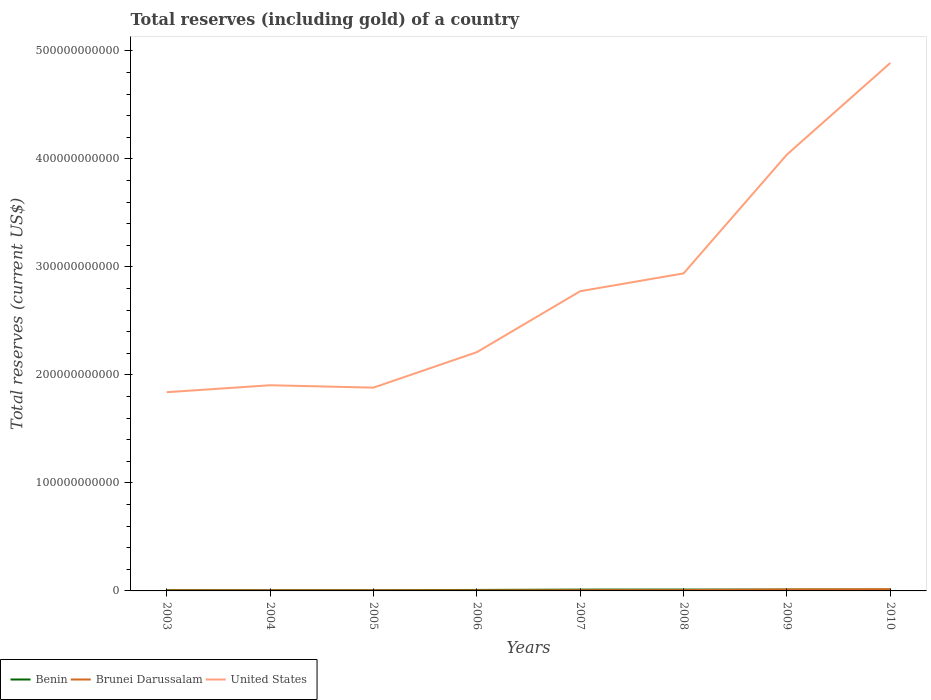How many different coloured lines are there?
Make the answer very short. 3. Does the line corresponding to United States intersect with the line corresponding to Brunei Darussalam?
Offer a terse response. No. Is the number of lines equal to the number of legend labels?
Your answer should be very brief. Yes. Across all years, what is the maximum total reserves (including gold) in United States?
Your answer should be compact. 1.84e+11. What is the total total reserves (including gold) in United States in the graph?
Your response must be concise. -9.35e+1. What is the difference between the highest and the second highest total reserves (including gold) in United States?
Your answer should be compact. 3.05e+11. How many years are there in the graph?
Provide a short and direct response. 8. What is the difference between two consecutive major ticks on the Y-axis?
Offer a very short reply. 1.00e+11. Are the values on the major ticks of Y-axis written in scientific E-notation?
Give a very brief answer. No. Does the graph contain any zero values?
Your answer should be compact. No. Does the graph contain grids?
Provide a succinct answer. No. How are the legend labels stacked?
Provide a succinct answer. Horizontal. What is the title of the graph?
Provide a short and direct response. Total reserves (including gold) of a country. What is the label or title of the X-axis?
Your answer should be compact. Years. What is the label or title of the Y-axis?
Give a very brief answer. Total reserves (current US$). What is the Total reserves (current US$) of Benin in 2003?
Make the answer very short. 7.18e+08. What is the Total reserves (current US$) of Brunei Darussalam in 2003?
Keep it short and to the point. 4.75e+08. What is the Total reserves (current US$) of United States in 2003?
Your answer should be compact. 1.84e+11. What is the Total reserves (current US$) of Benin in 2004?
Your response must be concise. 6.35e+08. What is the Total reserves (current US$) in Brunei Darussalam in 2004?
Give a very brief answer. 4.89e+08. What is the Total reserves (current US$) of United States in 2004?
Provide a succinct answer. 1.90e+11. What is the Total reserves (current US$) in Benin in 2005?
Provide a succinct answer. 6.55e+08. What is the Total reserves (current US$) in Brunei Darussalam in 2005?
Provide a short and direct response. 4.92e+08. What is the Total reserves (current US$) in United States in 2005?
Your answer should be compact. 1.88e+11. What is the Total reserves (current US$) of Benin in 2006?
Offer a very short reply. 9.12e+08. What is the Total reserves (current US$) in Brunei Darussalam in 2006?
Ensure brevity in your answer.  5.14e+08. What is the Total reserves (current US$) of United States in 2006?
Give a very brief answer. 2.21e+11. What is the Total reserves (current US$) of Benin in 2007?
Provide a short and direct response. 1.21e+09. What is the Total reserves (current US$) of Brunei Darussalam in 2007?
Provide a succinct answer. 6.67e+08. What is the Total reserves (current US$) of United States in 2007?
Provide a succinct answer. 2.78e+11. What is the Total reserves (current US$) in Benin in 2008?
Provide a short and direct response. 1.26e+09. What is the Total reserves (current US$) of Brunei Darussalam in 2008?
Provide a succinct answer. 7.51e+08. What is the Total reserves (current US$) in United States in 2008?
Offer a very short reply. 2.94e+11. What is the Total reserves (current US$) in Benin in 2009?
Keep it short and to the point. 1.23e+09. What is the Total reserves (current US$) of Brunei Darussalam in 2009?
Offer a very short reply. 1.36e+09. What is the Total reserves (current US$) in United States in 2009?
Ensure brevity in your answer.  4.04e+11. What is the Total reserves (current US$) in Benin in 2010?
Your answer should be very brief. 1.20e+09. What is the Total reserves (current US$) in Brunei Darussalam in 2010?
Offer a terse response. 1.56e+09. What is the Total reserves (current US$) of United States in 2010?
Offer a terse response. 4.89e+11. Across all years, what is the maximum Total reserves (current US$) in Benin?
Your answer should be very brief. 1.26e+09. Across all years, what is the maximum Total reserves (current US$) of Brunei Darussalam?
Your response must be concise. 1.56e+09. Across all years, what is the maximum Total reserves (current US$) of United States?
Your answer should be compact. 4.89e+11. Across all years, what is the minimum Total reserves (current US$) of Benin?
Provide a short and direct response. 6.35e+08. Across all years, what is the minimum Total reserves (current US$) of Brunei Darussalam?
Provide a succinct answer. 4.75e+08. Across all years, what is the minimum Total reserves (current US$) in United States?
Ensure brevity in your answer.  1.84e+11. What is the total Total reserves (current US$) in Benin in the graph?
Your response must be concise. 7.82e+09. What is the total Total reserves (current US$) in Brunei Darussalam in the graph?
Your answer should be compact. 6.31e+09. What is the total Total reserves (current US$) in United States in the graph?
Ensure brevity in your answer.  2.25e+12. What is the difference between the Total reserves (current US$) in Benin in 2003 and that in 2004?
Your answer should be very brief. 8.30e+07. What is the difference between the Total reserves (current US$) in Brunei Darussalam in 2003 and that in 2004?
Ensure brevity in your answer.  -1.41e+07. What is the difference between the Total reserves (current US$) in United States in 2003 and that in 2004?
Ensure brevity in your answer.  -6.44e+09. What is the difference between the Total reserves (current US$) of Benin in 2003 and that in 2005?
Ensure brevity in your answer.  6.33e+07. What is the difference between the Total reserves (current US$) in Brunei Darussalam in 2003 and that in 2005?
Make the answer very short. -1.71e+07. What is the difference between the Total reserves (current US$) of United States in 2003 and that in 2005?
Give a very brief answer. -4.23e+09. What is the difference between the Total reserves (current US$) of Benin in 2003 and that in 2006?
Your answer should be compact. -1.94e+08. What is the difference between the Total reserves (current US$) of Brunei Darussalam in 2003 and that in 2006?
Keep it short and to the point. -3.88e+07. What is the difference between the Total reserves (current US$) in United States in 2003 and that in 2006?
Offer a very short reply. -3.71e+1. What is the difference between the Total reserves (current US$) of Benin in 2003 and that in 2007?
Offer a terse response. -4.91e+08. What is the difference between the Total reserves (current US$) in Brunei Darussalam in 2003 and that in 2007?
Offer a terse response. -1.93e+08. What is the difference between the Total reserves (current US$) in United States in 2003 and that in 2007?
Your answer should be compact. -9.35e+1. What is the difference between the Total reserves (current US$) in Benin in 2003 and that in 2008?
Provide a short and direct response. -5.45e+08. What is the difference between the Total reserves (current US$) in Brunei Darussalam in 2003 and that in 2008?
Give a very brief answer. -2.76e+08. What is the difference between the Total reserves (current US$) in United States in 2003 and that in 2008?
Your answer should be compact. -1.10e+11. What is the difference between the Total reserves (current US$) of Benin in 2003 and that in 2009?
Provide a succinct answer. -5.12e+08. What is the difference between the Total reserves (current US$) of Brunei Darussalam in 2003 and that in 2009?
Make the answer very short. -8.83e+08. What is the difference between the Total reserves (current US$) in United States in 2003 and that in 2009?
Keep it short and to the point. -2.20e+11. What is the difference between the Total reserves (current US$) in Benin in 2003 and that in 2010?
Make the answer very short. -4.82e+08. What is the difference between the Total reserves (current US$) in Brunei Darussalam in 2003 and that in 2010?
Keep it short and to the point. -1.09e+09. What is the difference between the Total reserves (current US$) in United States in 2003 and that in 2010?
Keep it short and to the point. -3.05e+11. What is the difference between the Total reserves (current US$) of Benin in 2004 and that in 2005?
Offer a terse response. -1.97e+07. What is the difference between the Total reserves (current US$) of Brunei Darussalam in 2004 and that in 2005?
Ensure brevity in your answer.  -3.00e+06. What is the difference between the Total reserves (current US$) of United States in 2004 and that in 2005?
Offer a terse response. 2.21e+09. What is the difference between the Total reserves (current US$) of Benin in 2004 and that in 2006?
Provide a short and direct response. -2.77e+08. What is the difference between the Total reserves (current US$) in Brunei Darussalam in 2004 and that in 2006?
Your answer should be compact. -2.47e+07. What is the difference between the Total reserves (current US$) of United States in 2004 and that in 2006?
Offer a terse response. -3.06e+1. What is the difference between the Total reserves (current US$) in Benin in 2004 and that in 2007?
Make the answer very short. -5.74e+08. What is the difference between the Total reserves (current US$) of Brunei Darussalam in 2004 and that in 2007?
Your answer should be very brief. -1.79e+08. What is the difference between the Total reserves (current US$) of United States in 2004 and that in 2007?
Your answer should be very brief. -8.71e+1. What is the difference between the Total reserves (current US$) of Benin in 2004 and that in 2008?
Provide a succinct answer. -6.28e+08. What is the difference between the Total reserves (current US$) in Brunei Darussalam in 2004 and that in 2008?
Your answer should be compact. -2.62e+08. What is the difference between the Total reserves (current US$) of United States in 2004 and that in 2008?
Your response must be concise. -1.04e+11. What is the difference between the Total reserves (current US$) in Benin in 2004 and that in 2009?
Keep it short and to the point. -5.95e+08. What is the difference between the Total reserves (current US$) of Brunei Darussalam in 2004 and that in 2009?
Your response must be concise. -8.68e+08. What is the difference between the Total reserves (current US$) in United States in 2004 and that in 2009?
Provide a short and direct response. -2.14e+11. What is the difference between the Total reserves (current US$) in Benin in 2004 and that in 2010?
Offer a very short reply. -5.65e+08. What is the difference between the Total reserves (current US$) in Brunei Darussalam in 2004 and that in 2010?
Ensure brevity in your answer.  -1.07e+09. What is the difference between the Total reserves (current US$) of United States in 2004 and that in 2010?
Make the answer very short. -2.98e+11. What is the difference between the Total reserves (current US$) in Benin in 2005 and that in 2006?
Provide a short and direct response. -2.58e+08. What is the difference between the Total reserves (current US$) in Brunei Darussalam in 2005 and that in 2006?
Offer a very short reply. -2.17e+07. What is the difference between the Total reserves (current US$) in United States in 2005 and that in 2006?
Ensure brevity in your answer.  -3.28e+1. What is the difference between the Total reserves (current US$) in Benin in 2005 and that in 2007?
Your response must be concise. -5.55e+08. What is the difference between the Total reserves (current US$) of Brunei Darussalam in 2005 and that in 2007?
Offer a terse response. -1.76e+08. What is the difference between the Total reserves (current US$) of United States in 2005 and that in 2007?
Give a very brief answer. -8.93e+1. What is the difference between the Total reserves (current US$) of Benin in 2005 and that in 2008?
Your answer should be compact. -6.09e+08. What is the difference between the Total reserves (current US$) in Brunei Darussalam in 2005 and that in 2008?
Keep it short and to the point. -2.59e+08. What is the difference between the Total reserves (current US$) in United States in 2005 and that in 2008?
Provide a short and direct response. -1.06e+11. What is the difference between the Total reserves (current US$) of Benin in 2005 and that in 2009?
Offer a very short reply. -5.75e+08. What is the difference between the Total reserves (current US$) of Brunei Darussalam in 2005 and that in 2009?
Your response must be concise. -8.65e+08. What is the difference between the Total reserves (current US$) of United States in 2005 and that in 2009?
Your response must be concise. -2.16e+11. What is the difference between the Total reserves (current US$) in Benin in 2005 and that in 2010?
Offer a terse response. -5.46e+08. What is the difference between the Total reserves (current US$) in Brunei Darussalam in 2005 and that in 2010?
Keep it short and to the point. -1.07e+09. What is the difference between the Total reserves (current US$) of United States in 2005 and that in 2010?
Offer a very short reply. -3.01e+11. What is the difference between the Total reserves (current US$) of Benin in 2006 and that in 2007?
Offer a very short reply. -2.97e+08. What is the difference between the Total reserves (current US$) of Brunei Darussalam in 2006 and that in 2007?
Offer a terse response. -1.54e+08. What is the difference between the Total reserves (current US$) of United States in 2006 and that in 2007?
Ensure brevity in your answer.  -5.65e+1. What is the difference between the Total reserves (current US$) in Benin in 2006 and that in 2008?
Provide a short and direct response. -3.51e+08. What is the difference between the Total reserves (current US$) of Brunei Darussalam in 2006 and that in 2008?
Your answer should be compact. -2.38e+08. What is the difference between the Total reserves (current US$) of United States in 2006 and that in 2008?
Offer a terse response. -7.30e+1. What is the difference between the Total reserves (current US$) in Benin in 2006 and that in 2009?
Keep it short and to the point. -3.18e+08. What is the difference between the Total reserves (current US$) in Brunei Darussalam in 2006 and that in 2009?
Offer a very short reply. -8.44e+08. What is the difference between the Total reserves (current US$) in United States in 2006 and that in 2009?
Offer a very short reply. -1.83e+11. What is the difference between the Total reserves (current US$) in Benin in 2006 and that in 2010?
Keep it short and to the point. -2.88e+08. What is the difference between the Total reserves (current US$) of Brunei Darussalam in 2006 and that in 2010?
Provide a short and direct response. -1.05e+09. What is the difference between the Total reserves (current US$) in United States in 2006 and that in 2010?
Your response must be concise. -2.68e+11. What is the difference between the Total reserves (current US$) of Benin in 2007 and that in 2008?
Provide a short and direct response. -5.41e+07. What is the difference between the Total reserves (current US$) of Brunei Darussalam in 2007 and that in 2008?
Keep it short and to the point. -8.37e+07. What is the difference between the Total reserves (current US$) in United States in 2007 and that in 2008?
Your answer should be very brief. -1.65e+1. What is the difference between the Total reserves (current US$) in Benin in 2007 and that in 2009?
Give a very brief answer. -2.06e+07. What is the difference between the Total reserves (current US$) in Brunei Darussalam in 2007 and that in 2009?
Provide a succinct answer. -6.90e+08. What is the difference between the Total reserves (current US$) in United States in 2007 and that in 2009?
Offer a terse response. -1.27e+11. What is the difference between the Total reserves (current US$) in Benin in 2007 and that in 2010?
Provide a succinct answer. 9.15e+06. What is the difference between the Total reserves (current US$) in Brunei Darussalam in 2007 and that in 2010?
Your answer should be very brief. -8.96e+08. What is the difference between the Total reserves (current US$) of United States in 2007 and that in 2010?
Ensure brevity in your answer.  -2.11e+11. What is the difference between the Total reserves (current US$) in Benin in 2008 and that in 2009?
Keep it short and to the point. 3.35e+07. What is the difference between the Total reserves (current US$) of Brunei Darussalam in 2008 and that in 2009?
Keep it short and to the point. -6.06e+08. What is the difference between the Total reserves (current US$) of United States in 2008 and that in 2009?
Offer a terse response. -1.10e+11. What is the difference between the Total reserves (current US$) of Benin in 2008 and that in 2010?
Offer a very short reply. 6.33e+07. What is the difference between the Total reserves (current US$) in Brunei Darussalam in 2008 and that in 2010?
Make the answer very short. -8.12e+08. What is the difference between the Total reserves (current US$) of United States in 2008 and that in 2010?
Provide a short and direct response. -1.95e+11. What is the difference between the Total reserves (current US$) of Benin in 2009 and that in 2010?
Offer a terse response. 2.98e+07. What is the difference between the Total reserves (current US$) in Brunei Darussalam in 2009 and that in 2010?
Keep it short and to the point. -2.06e+08. What is the difference between the Total reserves (current US$) in United States in 2009 and that in 2010?
Make the answer very short. -8.48e+1. What is the difference between the Total reserves (current US$) of Benin in 2003 and the Total reserves (current US$) of Brunei Darussalam in 2004?
Your response must be concise. 2.29e+08. What is the difference between the Total reserves (current US$) of Benin in 2003 and the Total reserves (current US$) of United States in 2004?
Ensure brevity in your answer.  -1.90e+11. What is the difference between the Total reserves (current US$) in Brunei Darussalam in 2003 and the Total reserves (current US$) in United States in 2004?
Offer a very short reply. -1.90e+11. What is the difference between the Total reserves (current US$) in Benin in 2003 and the Total reserves (current US$) in Brunei Darussalam in 2005?
Provide a succinct answer. 2.26e+08. What is the difference between the Total reserves (current US$) in Benin in 2003 and the Total reserves (current US$) in United States in 2005?
Your response must be concise. -1.88e+11. What is the difference between the Total reserves (current US$) in Brunei Darussalam in 2003 and the Total reserves (current US$) in United States in 2005?
Keep it short and to the point. -1.88e+11. What is the difference between the Total reserves (current US$) of Benin in 2003 and the Total reserves (current US$) of Brunei Darussalam in 2006?
Ensure brevity in your answer.  2.04e+08. What is the difference between the Total reserves (current US$) of Benin in 2003 and the Total reserves (current US$) of United States in 2006?
Your answer should be compact. -2.20e+11. What is the difference between the Total reserves (current US$) of Brunei Darussalam in 2003 and the Total reserves (current US$) of United States in 2006?
Your answer should be very brief. -2.21e+11. What is the difference between the Total reserves (current US$) in Benin in 2003 and the Total reserves (current US$) in Brunei Darussalam in 2007?
Your response must be concise. 5.04e+07. What is the difference between the Total reserves (current US$) in Benin in 2003 and the Total reserves (current US$) in United States in 2007?
Offer a very short reply. -2.77e+11. What is the difference between the Total reserves (current US$) in Brunei Darussalam in 2003 and the Total reserves (current US$) in United States in 2007?
Your response must be concise. -2.77e+11. What is the difference between the Total reserves (current US$) of Benin in 2003 and the Total reserves (current US$) of Brunei Darussalam in 2008?
Give a very brief answer. -3.33e+07. What is the difference between the Total reserves (current US$) in Benin in 2003 and the Total reserves (current US$) in United States in 2008?
Ensure brevity in your answer.  -2.93e+11. What is the difference between the Total reserves (current US$) of Brunei Darussalam in 2003 and the Total reserves (current US$) of United States in 2008?
Offer a very short reply. -2.94e+11. What is the difference between the Total reserves (current US$) in Benin in 2003 and the Total reserves (current US$) in Brunei Darussalam in 2009?
Your response must be concise. -6.39e+08. What is the difference between the Total reserves (current US$) in Benin in 2003 and the Total reserves (current US$) in United States in 2009?
Provide a short and direct response. -4.03e+11. What is the difference between the Total reserves (current US$) of Brunei Darussalam in 2003 and the Total reserves (current US$) of United States in 2009?
Ensure brevity in your answer.  -4.04e+11. What is the difference between the Total reserves (current US$) in Benin in 2003 and the Total reserves (current US$) in Brunei Darussalam in 2010?
Make the answer very short. -8.45e+08. What is the difference between the Total reserves (current US$) of Benin in 2003 and the Total reserves (current US$) of United States in 2010?
Keep it short and to the point. -4.88e+11. What is the difference between the Total reserves (current US$) in Brunei Darussalam in 2003 and the Total reserves (current US$) in United States in 2010?
Give a very brief answer. -4.88e+11. What is the difference between the Total reserves (current US$) of Benin in 2004 and the Total reserves (current US$) of Brunei Darussalam in 2005?
Your answer should be compact. 1.43e+08. What is the difference between the Total reserves (current US$) in Benin in 2004 and the Total reserves (current US$) in United States in 2005?
Your answer should be compact. -1.88e+11. What is the difference between the Total reserves (current US$) of Brunei Darussalam in 2004 and the Total reserves (current US$) of United States in 2005?
Your answer should be very brief. -1.88e+11. What is the difference between the Total reserves (current US$) of Benin in 2004 and the Total reserves (current US$) of Brunei Darussalam in 2006?
Offer a terse response. 1.21e+08. What is the difference between the Total reserves (current US$) of Benin in 2004 and the Total reserves (current US$) of United States in 2006?
Make the answer very short. -2.20e+11. What is the difference between the Total reserves (current US$) in Brunei Darussalam in 2004 and the Total reserves (current US$) in United States in 2006?
Provide a succinct answer. -2.21e+11. What is the difference between the Total reserves (current US$) in Benin in 2004 and the Total reserves (current US$) in Brunei Darussalam in 2007?
Provide a short and direct response. -3.26e+07. What is the difference between the Total reserves (current US$) of Benin in 2004 and the Total reserves (current US$) of United States in 2007?
Your answer should be very brief. -2.77e+11. What is the difference between the Total reserves (current US$) in Brunei Darussalam in 2004 and the Total reserves (current US$) in United States in 2007?
Make the answer very short. -2.77e+11. What is the difference between the Total reserves (current US$) in Benin in 2004 and the Total reserves (current US$) in Brunei Darussalam in 2008?
Make the answer very short. -1.16e+08. What is the difference between the Total reserves (current US$) of Benin in 2004 and the Total reserves (current US$) of United States in 2008?
Your answer should be very brief. -2.93e+11. What is the difference between the Total reserves (current US$) of Brunei Darussalam in 2004 and the Total reserves (current US$) of United States in 2008?
Your answer should be compact. -2.94e+11. What is the difference between the Total reserves (current US$) in Benin in 2004 and the Total reserves (current US$) in Brunei Darussalam in 2009?
Offer a very short reply. -7.22e+08. What is the difference between the Total reserves (current US$) of Benin in 2004 and the Total reserves (current US$) of United States in 2009?
Offer a terse response. -4.03e+11. What is the difference between the Total reserves (current US$) in Brunei Darussalam in 2004 and the Total reserves (current US$) in United States in 2009?
Provide a succinct answer. -4.04e+11. What is the difference between the Total reserves (current US$) in Benin in 2004 and the Total reserves (current US$) in Brunei Darussalam in 2010?
Your answer should be very brief. -9.28e+08. What is the difference between the Total reserves (current US$) in Benin in 2004 and the Total reserves (current US$) in United States in 2010?
Your answer should be compact. -4.88e+11. What is the difference between the Total reserves (current US$) in Brunei Darussalam in 2004 and the Total reserves (current US$) in United States in 2010?
Provide a short and direct response. -4.88e+11. What is the difference between the Total reserves (current US$) of Benin in 2005 and the Total reserves (current US$) of Brunei Darussalam in 2006?
Provide a succinct answer. 1.41e+08. What is the difference between the Total reserves (current US$) in Benin in 2005 and the Total reserves (current US$) in United States in 2006?
Provide a succinct answer. -2.20e+11. What is the difference between the Total reserves (current US$) in Brunei Darussalam in 2005 and the Total reserves (current US$) in United States in 2006?
Ensure brevity in your answer.  -2.21e+11. What is the difference between the Total reserves (current US$) of Benin in 2005 and the Total reserves (current US$) of Brunei Darussalam in 2007?
Your response must be concise. -1.29e+07. What is the difference between the Total reserves (current US$) of Benin in 2005 and the Total reserves (current US$) of United States in 2007?
Keep it short and to the point. -2.77e+11. What is the difference between the Total reserves (current US$) in Brunei Darussalam in 2005 and the Total reserves (current US$) in United States in 2007?
Offer a terse response. -2.77e+11. What is the difference between the Total reserves (current US$) of Benin in 2005 and the Total reserves (current US$) of Brunei Darussalam in 2008?
Offer a very short reply. -9.66e+07. What is the difference between the Total reserves (current US$) of Benin in 2005 and the Total reserves (current US$) of United States in 2008?
Your response must be concise. -2.93e+11. What is the difference between the Total reserves (current US$) in Brunei Darussalam in 2005 and the Total reserves (current US$) in United States in 2008?
Your answer should be very brief. -2.94e+11. What is the difference between the Total reserves (current US$) in Benin in 2005 and the Total reserves (current US$) in Brunei Darussalam in 2009?
Make the answer very short. -7.03e+08. What is the difference between the Total reserves (current US$) in Benin in 2005 and the Total reserves (current US$) in United States in 2009?
Your response must be concise. -4.03e+11. What is the difference between the Total reserves (current US$) in Brunei Darussalam in 2005 and the Total reserves (current US$) in United States in 2009?
Provide a short and direct response. -4.04e+11. What is the difference between the Total reserves (current US$) of Benin in 2005 and the Total reserves (current US$) of Brunei Darussalam in 2010?
Make the answer very short. -9.09e+08. What is the difference between the Total reserves (current US$) in Benin in 2005 and the Total reserves (current US$) in United States in 2010?
Offer a very short reply. -4.88e+11. What is the difference between the Total reserves (current US$) of Brunei Darussalam in 2005 and the Total reserves (current US$) of United States in 2010?
Your answer should be very brief. -4.88e+11. What is the difference between the Total reserves (current US$) of Benin in 2006 and the Total reserves (current US$) of Brunei Darussalam in 2007?
Give a very brief answer. 2.45e+08. What is the difference between the Total reserves (current US$) of Benin in 2006 and the Total reserves (current US$) of United States in 2007?
Provide a succinct answer. -2.77e+11. What is the difference between the Total reserves (current US$) in Brunei Darussalam in 2006 and the Total reserves (current US$) in United States in 2007?
Your response must be concise. -2.77e+11. What is the difference between the Total reserves (current US$) in Benin in 2006 and the Total reserves (current US$) in Brunei Darussalam in 2008?
Offer a very short reply. 1.61e+08. What is the difference between the Total reserves (current US$) of Benin in 2006 and the Total reserves (current US$) of United States in 2008?
Ensure brevity in your answer.  -2.93e+11. What is the difference between the Total reserves (current US$) of Brunei Darussalam in 2006 and the Total reserves (current US$) of United States in 2008?
Your answer should be compact. -2.94e+11. What is the difference between the Total reserves (current US$) in Benin in 2006 and the Total reserves (current US$) in Brunei Darussalam in 2009?
Offer a terse response. -4.45e+08. What is the difference between the Total reserves (current US$) of Benin in 2006 and the Total reserves (current US$) of United States in 2009?
Provide a short and direct response. -4.03e+11. What is the difference between the Total reserves (current US$) in Brunei Darussalam in 2006 and the Total reserves (current US$) in United States in 2009?
Offer a terse response. -4.04e+11. What is the difference between the Total reserves (current US$) of Benin in 2006 and the Total reserves (current US$) of Brunei Darussalam in 2010?
Offer a very short reply. -6.51e+08. What is the difference between the Total reserves (current US$) in Benin in 2006 and the Total reserves (current US$) in United States in 2010?
Offer a very short reply. -4.88e+11. What is the difference between the Total reserves (current US$) of Brunei Darussalam in 2006 and the Total reserves (current US$) of United States in 2010?
Your answer should be very brief. -4.88e+11. What is the difference between the Total reserves (current US$) in Benin in 2007 and the Total reserves (current US$) in Brunei Darussalam in 2008?
Provide a short and direct response. 4.58e+08. What is the difference between the Total reserves (current US$) of Benin in 2007 and the Total reserves (current US$) of United States in 2008?
Keep it short and to the point. -2.93e+11. What is the difference between the Total reserves (current US$) of Brunei Darussalam in 2007 and the Total reserves (current US$) of United States in 2008?
Your answer should be very brief. -2.93e+11. What is the difference between the Total reserves (current US$) of Benin in 2007 and the Total reserves (current US$) of Brunei Darussalam in 2009?
Provide a short and direct response. -1.48e+08. What is the difference between the Total reserves (current US$) in Benin in 2007 and the Total reserves (current US$) in United States in 2009?
Ensure brevity in your answer.  -4.03e+11. What is the difference between the Total reserves (current US$) of Brunei Darussalam in 2007 and the Total reserves (current US$) of United States in 2009?
Provide a short and direct response. -4.03e+11. What is the difference between the Total reserves (current US$) of Benin in 2007 and the Total reserves (current US$) of Brunei Darussalam in 2010?
Keep it short and to the point. -3.54e+08. What is the difference between the Total reserves (current US$) in Benin in 2007 and the Total reserves (current US$) in United States in 2010?
Keep it short and to the point. -4.88e+11. What is the difference between the Total reserves (current US$) of Brunei Darussalam in 2007 and the Total reserves (current US$) of United States in 2010?
Ensure brevity in your answer.  -4.88e+11. What is the difference between the Total reserves (current US$) of Benin in 2008 and the Total reserves (current US$) of Brunei Darussalam in 2009?
Your answer should be compact. -9.39e+07. What is the difference between the Total reserves (current US$) in Benin in 2008 and the Total reserves (current US$) in United States in 2009?
Give a very brief answer. -4.03e+11. What is the difference between the Total reserves (current US$) in Brunei Darussalam in 2008 and the Total reserves (current US$) in United States in 2009?
Make the answer very short. -4.03e+11. What is the difference between the Total reserves (current US$) in Benin in 2008 and the Total reserves (current US$) in Brunei Darussalam in 2010?
Provide a short and direct response. -3.00e+08. What is the difference between the Total reserves (current US$) of Benin in 2008 and the Total reserves (current US$) of United States in 2010?
Make the answer very short. -4.88e+11. What is the difference between the Total reserves (current US$) of Brunei Darussalam in 2008 and the Total reserves (current US$) of United States in 2010?
Your answer should be compact. -4.88e+11. What is the difference between the Total reserves (current US$) in Benin in 2009 and the Total reserves (current US$) in Brunei Darussalam in 2010?
Give a very brief answer. -3.33e+08. What is the difference between the Total reserves (current US$) in Benin in 2009 and the Total reserves (current US$) in United States in 2010?
Give a very brief answer. -4.88e+11. What is the difference between the Total reserves (current US$) in Brunei Darussalam in 2009 and the Total reserves (current US$) in United States in 2010?
Keep it short and to the point. -4.88e+11. What is the average Total reserves (current US$) of Benin per year?
Ensure brevity in your answer.  9.78e+08. What is the average Total reserves (current US$) in Brunei Darussalam per year?
Make the answer very short. 7.89e+08. What is the average Total reserves (current US$) in United States per year?
Keep it short and to the point. 2.81e+11. In the year 2003, what is the difference between the Total reserves (current US$) in Benin and Total reserves (current US$) in Brunei Darussalam?
Provide a short and direct response. 2.43e+08. In the year 2003, what is the difference between the Total reserves (current US$) of Benin and Total reserves (current US$) of United States?
Make the answer very short. -1.83e+11. In the year 2003, what is the difference between the Total reserves (current US$) in Brunei Darussalam and Total reserves (current US$) in United States?
Offer a very short reply. -1.84e+11. In the year 2004, what is the difference between the Total reserves (current US$) of Benin and Total reserves (current US$) of Brunei Darussalam?
Keep it short and to the point. 1.46e+08. In the year 2004, what is the difference between the Total reserves (current US$) of Benin and Total reserves (current US$) of United States?
Ensure brevity in your answer.  -1.90e+11. In the year 2004, what is the difference between the Total reserves (current US$) in Brunei Darussalam and Total reserves (current US$) in United States?
Give a very brief answer. -1.90e+11. In the year 2005, what is the difference between the Total reserves (current US$) in Benin and Total reserves (current US$) in Brunei Darussalam?
Offer a terse response. 1.63e+08. In the year 2005, what is the difference between the Total reserves (current US$) of Benin and Total reserves (current US$) of United States?
Your answer should be compact. -1.88e+11. In the year 2005, what is the difference between the Total reserves (current US$) in Brunei Darussalam and Total reserves (current US$) in United States?
Your response must be concise. -1.88e+11. In the year 2006, what is the difference between the Total reserves (current US$) of Benin and Total reserves (current US$) of Brunei Darussalam?
Make the answer very short. 3.99e+08. In the year 2006, what is the difference between the Total reserves (current US$) of Benin and Total reserves (current US$) of United States?
Your answer should be compact. -2.20e+11. In the year 2006, what is the difference between the Total reserves (current US$) in Brunei Darussalam and Total reserves (current US$) in United States?
Keep it short and to the point. -2.21e+11. In the year 2007, what is the difference between the Total reserves (current US$) in Benin and Total reserves (current US$) in Brunei Darussalam?
Ensure brevity in your answer.  5.42e+08. In the year 2007, what is the difference between the Total reserves (current US$) in Benin and Total reserves (current US$) in United States?
Make the answer very short. -2.76e+11. In the year 2007, what is the difference between the Total reserves (current US$) of Brunei Darussalam and Total reserves (current US$) of United States?
Your response must be concise. -2.77e+11. In the year 2008, what is the difference between the Total reserves (current US$) of Benin and Total reserves (current US$) of Brunei Darussalam?
Your response must be concise. 5.12e+08. In the year 2008, what is the difference between the Total reserves (current US$) in Benin and Total reserves (current US$) in United States?
Your answer should be compact. -2.93e+11. In the year 2008, what is the difference between the Total reserves (current US$) in Brunei Darussalam and Total reserves (current US$) in United States?
Your answer should be compact. -2.93e+11. In the year 2009, what is the difference between the Total reserves (current US$) in Benin and Total reserves (current US$) in Brunei Darussalam?
Keep it short and to the point. -1.27e+08. In the year 2009, what is the difference between the Total reserves (current US$) in Benin and Total reserves (current US$) in United States?
Your response must be concise. -4.03e+11. In the year 2009, what is the difference between the Total reserves (current US$) of Brunei Darussalam and Total reserves (current US$) of United States?
Keep it short and to the point. -4.03e+11. In the year 2010, what is the difference between the Total reserves (current US$) of Benin and Total reserves (current US$) of Brunei Darussalam?
Make the answer very short. -3.63e+08. In the year 2010, what is the difference between the Total reserves (current US$) of Benin and Total reserves (current US$) of United States?
Make the answer very short. -4.88e+11. In the year 2010, what is the difference between the Total reserves (current US$) in Brunei Darussalam and Total reserves (current US$) in United States?
Make the answer very short. -4.87e+11. What is the ratio of the Total reserves (current US$) in Benin in 2003 to that in 2004?
Provide a succinct answer. 1.13. What is the ratio of the Total reserves (current US$) in Brunei Darussalam in 2003 to that in 2004?
Offer a terse response. 0.97. What is the ratio of the Total reserves (current US$) in United States in 2003 to that in 2004?
Your answer should be compact. 0.97. What is the ratio of the Total reserves (current US$) in Benin in 2003 to that in 2005?
Offer a very short reply. 1.1. What is the ratio of the Total reserves (current US$) of Brunei Darussalam in 2003 to that in 2005?
Make the answer very short. 0.97. What is the ratio of the Total reserves (current US$) of United States in 2003 to that in 2005?
Make the answer very short. 0.98. What is the ratio of the Total reserves (current US$) in Benin in 2003 to that in 2006?
Your answer should be compact. 0.79. What is the ratio of the Total reserves (current US$) in Brunei Darussalam in 2003 to that in 2006?
Ensure brevity in your answer.  0.92. What is the ratio of the Total reserves (current US$) in United States in 2003 to that in 2006?
Give a very brief answer. 0.83. What is the ratio of the Total reserves (current US$) of Benin in 2003 to that in 2007?
Give a very brief answer. 0.59. What is the ratio of the Total reserves (current US$) in Brunei Darussalam in 2003 to that in 2007?
Your answer should be compact. 0.71. What is the ratio of the Total reserves (current US$) of United States in 2003 to that in 2007?
Offer a very short reply. 0.66. What is the ratio of the Total reserves (current US$) of Benin in 2003 to that in 2008?
Make the answer very short. 0.57. What is the ratio of the Total reserves (current US$) of Brunei Darussalam in 2003 to that in 2008?
Offer a very short reply. 0.63. What is the ratio of the Total reserves (current US$) of United States in 2003 to that in 2008?
Your answer should be very brief. 0.63. What is the ratio of the Total reserves (current US$) in Benin in 2003 to that in 2009?
Keep it short and to the point. 0.58. What is the ratio of the Total reserves (current US$) of Brunei Darussalam in 2003 to that in 2009?
Ensure brevity in your answer.  0.35. What is the ratio of the Total reserves (current US$) in United States in 2003 to that in 2009?
Ensure brevity in your answer.  0.46. What is the ratio of the Total reserves (current US$) in Benin in 2003 to that in 2010?
Give a very brief answer. 0.6. What is the ratio of the Total reserves (current US$) of Brunei Darussalam in 2003 to that in 2010?
Keep it short and to the point. 0.3. What is the ratio of the Total reserves (current US$) in United States in 2003 to that in 2010?
Ensure brevity in your answer.  0.38. What is the ratio of the Total reserves (current US$) in United States in 2004 to that in 2005?
Your answer should be very brief. 1.01. What is the ratio of the Total reserves (current US$) of Benin in 2004 to that in 2006?
Provide a short and direct response. 0.7. What is the ratio of the Total reserves (current US$) of Brunei Darussalam in 2004 to that in 2006?
Provide a short and direct response. 0.95. What is the ratio of the Total reserves (current US$) of United States in 2004 to that in 2006?
Offer a terse response. 0.86. What is the ratio of the Total reserves (current US$) in Benin in 2004 to that in 2007?
Make the answer very short. 0.53. What is the ratio of the Total reserves (current US$) of Brunei Darussalam in 2004 to that in 2007?
Offer a terse response. 0.73. What is the ratio of the Total reserves (current US$) of United States in 2004 to that in 2007?
Ensure brevity in your answer.  0.69. What is the ratio of the Total reserves (current US$) of Benin in 2004 to that in 2008?
Ensure brevity in your answer.  0.5. What is the ratio of the Total reserves (current US$) of Brunei Darussalam in 2004 to that in 2008?
Your response must be concise. 0.65. What is the ratio of the Total reserves (current US$) in United States in 2004 to that in 2008?
Your answer should be very brief. 0.65. What is the ratio of the Total reserves (current US$) in Benin in 2004 to that in 2009?
Your answer should be very brief. 0.52. What is the ratio of the Total reserves (current US$) in Brunei Darussalam in 2004 to that in 2009?
Offer a very short reply. 0.36. What is the ratio of the Total reserves (current US$) of United States in 2004 to that in 2009?
Provide a short and direct response. 0.47. What is the ratio of the Total reserves (current US$) of Benin in 2004 to that in 2010?
Keep it short and to the point. 0.53. What is the ratio of the Total reserves (current US$) in Brunei Darussalam in 2004 to that in 2010?
Your response must be concise. 0.31. What is the ratio of the Total reserves (current US$) of United States in 2004 to that in 2010?
Provide a succinct answer. 0.39. What is the ratio of the Total reserves (current US$) in Benin in 2005 to that in 2006?
Provide a succinct answer. 0.72. What is the ratio of the Total reserves (current US$) in Brunei Darussalam in 2005 to that in 2006?
Your answer should be very brief. 0.96. What is the ratio of the Total reserves (current US$) of United States in 2005 to that in 2006?
Make the answer very short. 0.85. What is the ratio of the Total reserves (current US$) of Benin in 2005 to that in 2007?
Provide a succinct answer. 0.54. What is the ratio of the Total reserves (current US$) of Brunei Darussalam in 2005 to that in 2007?
Ensure brevity in your answer.  0.74. What is the ratio of the Total reserves (current US$) in United States in 2005 to that in 2007?
Offer a very short reply. 0.68. What is the ratio of the Total reserves (current US$) in Benin in 2005 to that in 2008?
Provide a short and direct response. 0.52. What is the ratio of the Total reserves (current US$) of Brunei Darussalam in 2005 to that in 2008?
Your answer should be very brief. 0.65. What is the ratio of the Total reserves (current US$) in United States in 2005 to that in 2008?
Make the answer very short. 0.64. What is the ratio of the Total reserves (current US$) in Benin in 2005 to that in 2009?
Offer a terse response. 0.53. What is the ratio of the Total reserves (current US$) of Brunei Darussalam in 2005 to that in 2009?
Make the answer very short. 0.36. What is the ratio of the Total reserves (current US$) in United States in 2005 to that in 2009?
Offer a terse response. 0.47. What is the ratio of the Total reserves (current US$) in Benin in 2005 to that in 2010?
Your answer should be compact. 0.55. What is the ratio of the Total reserves (current US$) of Brunei Darussalam in 2005 to that in 2010?
Your answer should be very brief. 0.31. What is the ratio of the Total reserves (current US$) of United States in 2005 to that in 2010?
Offer a terse response. 0.39. What is the ratio of the Total reserves (current US$) in Benin in 2006 to that in 2007?
Give a very brief answer. 0.75. What is the ratio of the Total reserves (current US$) of Brunei Darussalam in 2006 to that in 2007?
Ensure brevity in your answer.  0.77. What is the ratio of the Total reserves (current US$) in United States in 2006 to that in 2007?
Ensure brevity in your answer.  0.8. What is the ratio of the Total reserves (current US$) of Benin in 2006 to that in 2008?
Your response must be concise. 0.72. What is the ratio of the Total reserves (current US$) of Brunei Darussalam in 2006 to that in 2008?
Make the answer very short. 0.68. What is the ratio of the Total reserves (current US$) of United States in 2006 to that in 2008?
Make the answer very short. 0.75. What is the ratio of the Total reserves (current US$) in Benin in 2006 to that in 2009?
Provide a short and direct response. 0.74. What is the ratio of the Total reserves (current US$) in Brunei Darussalam in 2006 to that in 2009?
Give a very brief answer. 0.38. What is the ratio of the Total reserves (current US$) in United States in 2006 to that in 2009?
Provide a short and direct response. 0.55. What is the ratio of the Total reserves (current US$) of Benin in 2006 to that in 2010?
Give a very brief answer. 0.76. What is the ratio of the Total reserves (current US$) of Brunei Darussalam in 2006 to that in 2010?
Provide a succinct answer. 0.33. What is the ratio of the Total reserves (current US$) in United States in 2006 to that in 2010?
Give a very brief answer. 0.45. What is the ratio of the Total reserves (current US$) of Benin in 2007 to that in 2008?
Keep it short and to the point. 0.96. What is the ratio of the Total reserves (current US$) of Brunei Darussalam in 2007 to that in 2008?
Ensure brevity in your answer.  0.89. What is the ratio of the Total reserves (current US$) in United States in 2007 to that in 2008?
Give a very brief answer. 0.94. What is the ratio of the Total reserves (current US$) of Benin in 2007 to that in 2009?
Make the answer very short. 0.98. What is the ratio of the Total reserves (current US$) of Brunei Darussalam in 2007 to that in 2009?
Provide a succinct answer. 0.49. What is the ratio of the Total reserves (current US$) in United States in 2007 to that in 2009?
Your answer should be compact. 0.69. What is the ratio of the Total reserves (current US$) in Benin in 2007 to that in 2010?
Provide a short and direct response. 1.01. What is the ratio of the Total reserves (current US$) in Brunei Darussalam in 2007 to that in 2010?
Offer a very short reply. 0.43. What is the ratio of the Total reserves (current US$) of United States in 2007 to that in 2010?
Give a very brief answer. 0.57. What is the ratio of the Total reserves (current US$) in Benin in 2008 to that in 2009?
Give a very brief answer. 1.03. What is the ratio of the Total reserves (current US$) in Brunei Darussalam in 2008 to that in 2009?
Your answer should be compact. 0.55. What is the ratio of the Total reserves (current US$) in United States in 2008 to that in 2009?
Give a very brief answer. 0.73. What is the ratio of the Total reserves (current US$) of Benin in 2008 to that in 2010?
Your answer should be very brief. 1.05. What is the ratio of the Total reserves (current US$) in Brunei Darussalam in 2008 to that in 2010?
Give a very brief answer. 0.48. What is the ratio of the Total reserves (current US$) in United States in 2008 to that in 2010?
Your response must be concise. 0.6. What is the ratio of the Total reserves (current US$) in Benin in 2009 to that in 2010?
Offer a very short reply. 1.02. What is the ratio of the Total reserves (current US$) in Brunei Darussalam in 2009 to that in 2010?
Your response must be concise. 0.87. What is the ratio of the Total reserves (current US$) of United States in 2009 to that in 2010?
Ensure brevity in your answer.  0.83. What is the difference between the highest and the second highest Total reserves (current US$) in Benin?
Provide a succinct answer. 3.35e+07. What is the difference between the highest and the second highest Total reserves (current US$) in Brunei Darussalam?
Your response must be concise. 2.06e+08. What is the difference between the highest and the second highest Total reserves (current US$) in United States?
Make the answer very short. 8.48e+1. What is the difference between the highest and the lowest Total reserves (current US$) in Benin?
Your response must be concise. 6.28e+08. What is the difference between the highest and the lowest Total reserves (current US$) of Brunei Darussalam?
Make the answer very short. 1.09e+09. What is the difference between the highest and the lowest Total reserves (current US$) of United States?
Give a very brief answer. 3.05e+11. 